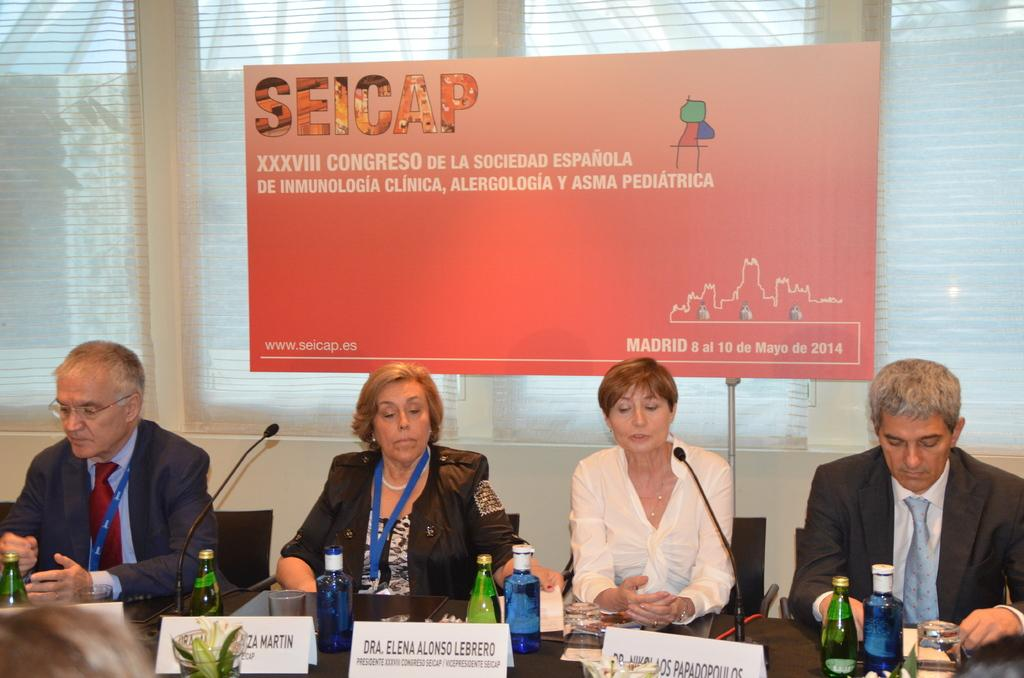<image>
Describe the image concisely. Four people hold a meeting for SEICAP in Madrid. 